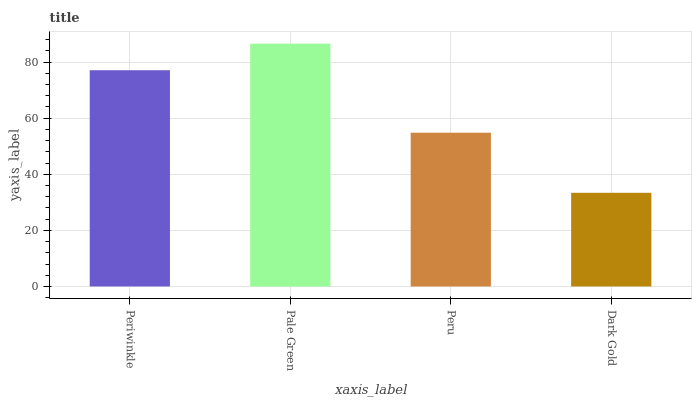Is Dark Gold the minimum?
Answer yes or no. Yes. Is Pale Green the maximum?
Answer yes or no. Yes. Is Peru the minimum?
Answer yes or no. No. Is Peru the maximum?
Answer yes or no. No. Is Pale Green greater than Peru?
Answer yes or no. Yes. Is Peru less than Pale Green?
Answer yes or no. Yes. Is Peru greater than Pale Green?
Answer yes or no. No. Is Pale Green less than Peru?
Answer yes or no. No. Is Periwinkle the high median?
Answer yes or no. Yes. Is Peru the low median?
Answer yes or no. Yes. Is Pale Green the high median?
Answer yes or no. No. Is Periwinkle the low median?
Answer yes or no. No. 